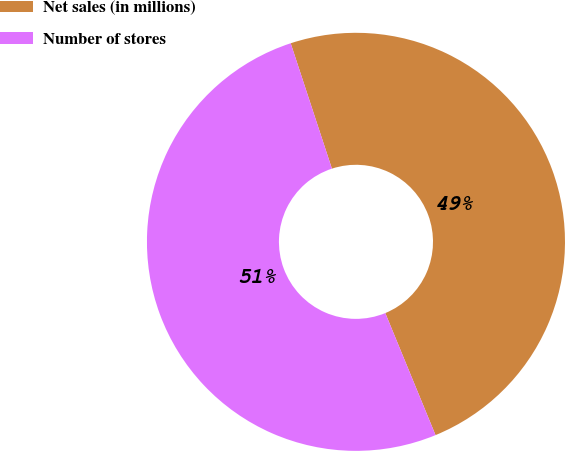Convert chart. <chart><loc_0><loc_0><loc_500><loc_500><pie_chart><fcel>Net sales (in millions)<fcel>Number of stores<nl><fcel>48.84%<fcel>51.16%<nl></chart> 